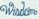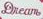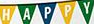What words can you see in these images in sequence, separated by a semicolon? ####; Dream; HAPPY 